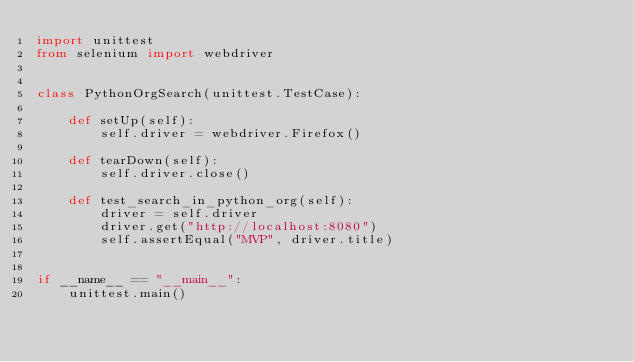Convert code to text. <code><loc_0><loc_0><loc_500><loc_500><_Python_>import unittest
from selenium import webdriver


class PythonOrgSearch(unittest.TestCase):

    def setUp(self):
        self.driver = webdriver.Firefox()

    def tearDown(self):
        self.driver.close()

    def test_search_in_python_org(self):
        driver = self.driver
        driver.get("http://localhost:8080")
        self.assertEqual("MVP", driver.title)


if __name__ == "__main__":
    unittest.main()
</code> 